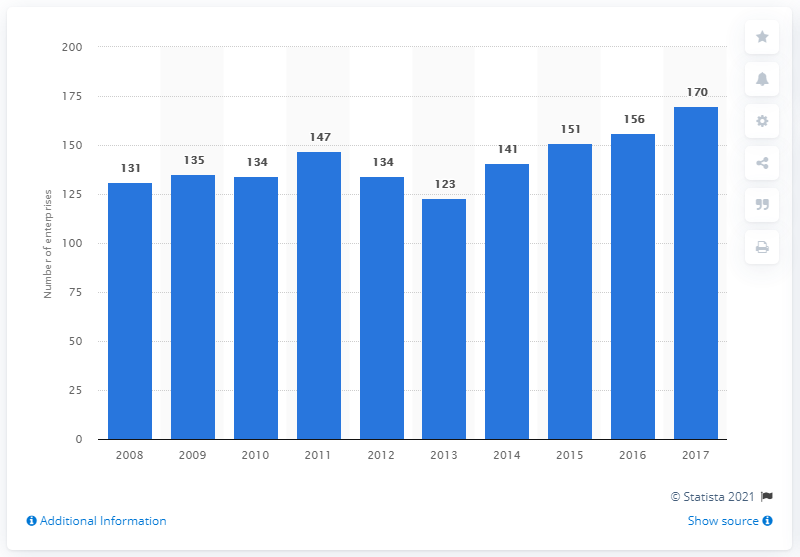Outline some significant characteristics in this image. In 2017, there were 170 enterprises operating in Bulgaria's cocoa, chocolate, and sugar confectionery industry. 